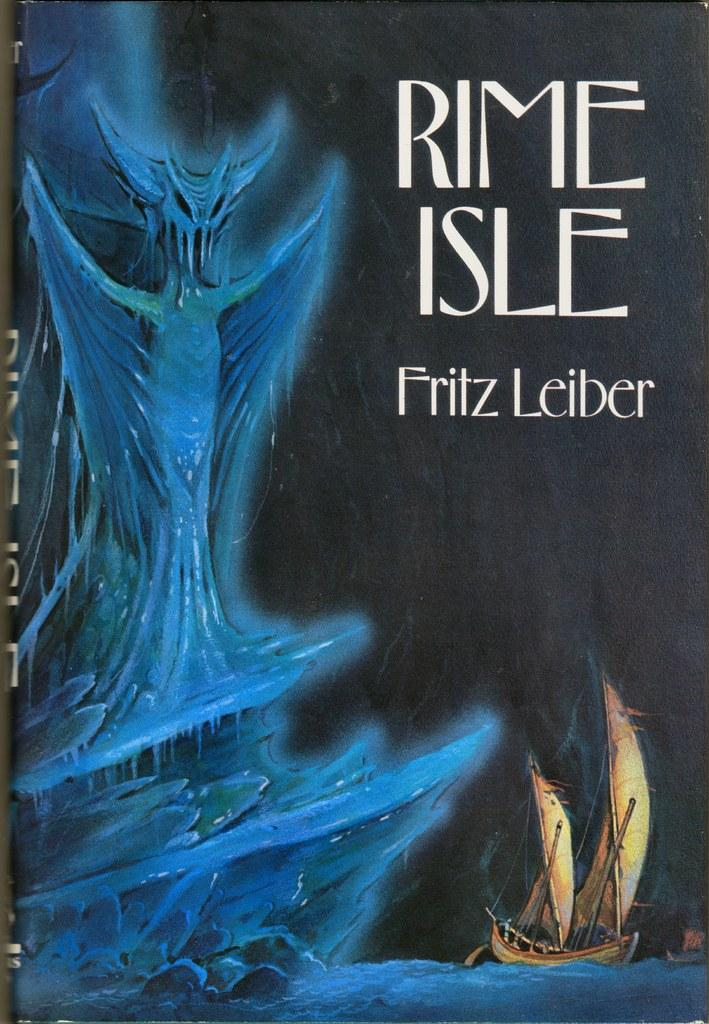What is featured on the poster in the image? The poster contains images of boats and water. What else can be seen on the poster besides the images? There is text on the poster. Can you tell me how many people are wearing hats in the image? There are no people or hats present in the image; it only features a poster with images of boats and water, along with text. 